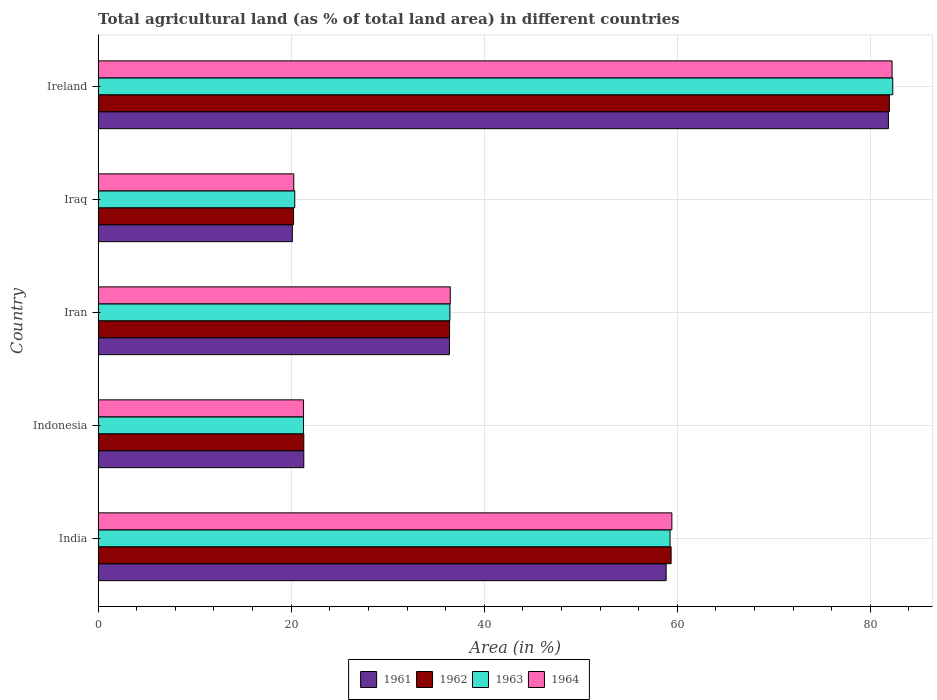Are the number of bars on each tick of the Y-axis equal?
Make the answer very short. Yes. What is the label of the 5th group of bars from the top?
Your answer should be compact. India. What is the percentage of agricultural land in 1963 in Indonesia?
Your answer should be compact. 21.28. Across all countries, what is the maximum percentage of agricultural land in 1962?
Ensure brevity in your answer.  81.97. Across all countries, what is the minimum percentage of agricultural land in 1964?
Offer a very short reply. 20.27. In which country was the percentage of agricultural land in 1964 maximum?
Give a very brief answer. Ireland. In which country was the percentage of agricultural land in 1962 minimum?
Your answer should be compact. Iraq. What is the total percentage of agricultural land in 1964 in the graph?
Provide a short and direct response. 219.71. What is the difference between the percentage of agricultural land in 1963 in Indonesia and that in Iraq?
Your response must be concise. 0.91. What is the difference between the percentage of agricultural land in 1962 in India and the percentage of agricultural land in 1961 in Iran?
Keep it short and to the point. 22.96. What is the average percentage of agricultural land in 1963 per country?
Offer a terse response. 43.93. What is the difference between the percentage of agricultural land in 1961 and percentage of agricultural land in 1964 in India?
Provide a short and direct response. -0.59. In how many countries, is the percentage of agricultural land in 1961 greater than 28 %?
Provide a short and direct response. 3. What is the ratio of the percentage of agricultural land in 1961 in Indonesia to that in Ireland?
Your answer should be compact. 0.26. Is the percentage of agricultural land in 1961 in India less than that in Iran?
Your answer should be compact. No. What is the difference between the highest and the second highest percentage of agricultural land in 1961?
Offer a terse response. 23.03. What is the difference between the highest and the lowest percentage of agricultural land in 1964?
Offer a very short reply. 61.98. Is the sum of the percentage of agricultural land in 1963 in Indonesia and Ireland greater than the maximum percentage of agricultural land in 1962 across all countries?
Ensure brevity in your answer.  Yes. What does the 4th bar from the top in Indonesia represents?
Provide a succinct answer. 1961. How many bars are there?
Your response must be concise. 20. Are all the bars in the graph horizontal?
Offer a very short reply. Yes. How many countries are there in the graph?
Your answer should be very brief. 5. What is the difference between two consecutive major ticks on the X-axis?
Provide a succinct answer. 20. Does the graph contain any zero values?
Your answer should be compact. No. How are the legend labels stacked?
Give a very brief answer. Horizontal. What is the title of the graph?
Offer a terse response. Total agricultural land (as % of total land area) in different countries. What is the label or title of the X-axis?
Make the answer very short. Area (in %). What is the Area (in %) of 1961 in India?
Provide a succinct answer. 58.84. What is the Area (in %) of 1962 in India?
Your answer should be very brief. 59.36. What is the Area (in %) in 1963 in India?
Your answer should be very brief. 59.25. What is the Area (in %) in 1964 in India?
Keep it short and to the point. 59.44. What is the Area (in %) of 1961 in Indonesia?
Make the answer very short. 21.31. What is the Area (in %) in 1962 in Indonesia?
Keep it short and to the point. 21.31. What is the Area (in %) in 1963 in Indonesia?
Your answer should be very brief. 21.28. What is the Area (in %) of 1964 in Indonesia?
Offer a terse response. 21.28. What is the Area (in %) in 1961 in Iran?
Make the answer very short. 36.39. What is the Area (in %) of 1962 in Iran?
Your answer should be very brief. 36.41. What is the Area (in %) of 1963 in Iran?
Your response must be concise. 36.44. What is the Area (in %) in 1964 in Iran?
Your answer should be compact. 36.48. What is the Area (in %) in 1961 in Iraq?
Your answer should be compact. 20.12. What is the Area (in %) in 1962 in Iraq?
Provide a succinct answer. 20.25. What is the Area (in %) in 1963 in Iraq?
Offer a very short reply. 20.37. What is the Area (in %) in 1964 in Iraq?
Offer a terse response. 20.27. What is the Area (in %) of 1961 in Ireland?
Keep it short and to the point. 81.87. What is the Area (in %) in 1962 in Ireland?
Make the answer very short. 81.97. What is the Area (in %) of 1963 in Ireland?
Your answer should be very brief. 82.32. What is the Area (in %) in 1964 in Ireland?
Ensure brevity in your answer.  82.25. Across all countries, what is the maximum Area (in %) in 1961?
Your answer should be compact. 81.87. Across all countries, what is the maximum Area (in %) of 1962?
Your answer should be very brief. 81.97. Across all countries, what is the maximum Area (in %) in 1963?
Make the answer very short. 82.32. Across all countries, what is the maximum Area (in %) of 1964?
Offer a very short reply. 82.25. Across all countries, what is the minimum Area (in %) in 1961?
Your response must be concise. 20.12. Across all countries, what is the minimum Area (in %) in 1962?
Keep it short and to the point. 20.25. Across all countries, what is the minimum Area (in %) in 1963?
Give a very brief answer. 20.37. Across all countries, what is the minimum Area (in %) in 1964?
Your answer should be compact. 20.27. What is the total Area (in %) in 1961 in the graph?
Your answer should be very brief. 218.54. What is the total Area (in %) in 1962 in the graph?
Provide a succinct answer. 219.29. What is the total Area (in %) in 1963 in the graph?
Your response must be concise. 219.66. What is the total Area (in %) of 1964 in the graph?
Provide a succinct answer. 219.71. What is the difference between the Area (in %) in 1961 in India and that in Indonesia?
Provide a succinct answer. 37.54. What is the difference between the Area (in %) in 1962 in India and that in Indonesia?
Offer a terse response. 38.05. What is the difference between the Area (in %) in 1963 in India and that in Indonesia?
Make the answer very short. 37.97. What is the difference between the Area (in %) of 1964 in India and that in Indonesia?
Keep it short and to the point. 38.16. What is the difference between the Area (in %) of 1961 in India and that in Iran?
Give a very brief answer. 22.45. What is the difference between the Area (in %) in 1962 in India and that in Iran?
Offer a terse response. 22.95. What is the difference between the Area (in %) in 1963 in India and that in Iran?
Give a very brief answer. 22.8. What is the difference between the Area (in %) in 1964 in India and that in Iran?
Your answer should be compact. 22.95. What is the difference between the Area (in %) in 1961 in India and that in Iraq?
Your response must be concise. 38.72. What is the difference between the Area (in %) in 1962 in India and that in Iraq?
Make the answer very short. 39.11. What is the difference between the Area (in %) of 1963 in India and that in Iraq?
Keep it short and to the point. 38.88. What is the difference between the Area (in %) of 1964 in India and that in Iraq?
Provide a succinct answer. 39.17. What is the difference between the Area (in %) of 1961 in India and that in Ireland?
Ensure brevity in your answer.  -23.03. What is the difference between the Area (in %) of 1962 in India and that in Ireland?
Provide a succinct answer. -22.61. What is the difference between the Area (in %) of 1963 in India and that in Ireland?
Your answer should be very brief. -23.07. What is the difference between the Area (in %) of 1964 in India and that in Ireland?
Keep it short and to the point. -22.81. What is the difference between the Area (in %) in 1961 in Indonesia and that in Iran?
Ensure brevity in your answer.  -15.09. What is the difference between the Area (in %) of 1962 in Indonesia and that in Iran?
Keep it short and to the point. -15.1. What is the difference between the Area (in %) in 1963 in Indonesia and that in Iran?
Offer a terse response. -15.16. What is the difference between the Area (in %) in 1964 in Indonesia and that in Iran?
Your answer should be very brief. -15.2. What is the difference between the Area (in %) of 1961 in Indonesia and that in Iraq?
Ensure brevity in your answer.  1.19. What is the difference between the Area (in %) of 1962 in Indonesia and that in Iraq?
Offer a very short reply. 1.06. What is the difference between the Area (in %) of 1963 in Indonesia and that in Iraq?
Your answer should be very brief. 0.91. What is the difference between the Area (in %) in 1964 in Indonesia and that in Iraq?
Make the answer very short. 1.01. What is the difference between the Area (in %) in 1961 in Indonesia and that in Ireland?
Your response must be concise. -60.56. What is the difference between the Area (in %) in 1962 in Indonesia and that in Ireland?
Provide a short and direct response. -60.66. What is the difference between the Area (in %) in 1963 in Indonesia and that in Ireland?
Give a very brief answer. -61.04. What is the difference between the Area (in %) in 1964 in Indonesia and that in Ireland?
Give a very brief answer. -60.97. What is the difference between the Area (in %) in 1961 in Iran and that in Iraq?
Ensure brevity in your answer.  16.27. What is the difference between the Area (in %) of 1962 in Iran and that in Iraq?
Your answer should be compact. 16.16. What is the difference between the Area (in %) in 1963 in Iran and that in Iraq?
Offer a very short reply. 16.07. What is the difference between the Area (in %) in 1964 in Iran and that in Iraq?
Your response must be concise. 16.21. What is the difference between the Area (in %) in 1961 in Iran and that in Ireland?
Keep it short and to the point. -45.47. What is the difference between the Area (in %) in 1962 in Iran and that in Ireland?
Ensure brevity in your answer.  -45.56. What is the difference between the Area (in %) of 1963 in Iran and that in Ireland?
Provide a succinct answer. -45.88. What is the difference between the Area (in %) in 1964 in Iran and that in Ireland?
Keep it short and to the point. -45.77. What is the difference between the Area (in %) in 1961 in Iraq and that in Ireland?
Provide a succinct answer. -61.75. What is the difference between the Area (in %) in 1962 in Iraq and that in Ireland?
Give a very brief answer. -61.73. What is the difference between the Area (in %) of 1963 in Iraq and that in Ireland?
Make the answer very short. -61.95. What is the difference between the Area (in %) of 1964 in Iraq and that in Ireland?
Provide a succinct answer. -61.98. What is the difference between the Area (in %) in 1961 in India and the Area (in %) in 1962 in Indonesia?
Offer a very short reply. 37.54. What is the difference between the Area (in %) in 1961 in India and the Area (in %) in 1963 in Indonesia?
Keep it short and to the point. 37.56. What is the difference between the Area (in %) of 1961 in India and the Area (in %) of 1964 in Indonesia?
Provide a short and direct response. 37.56. What is the difference between the Area (in %) in 1962 in India and the Area (in %) in 1963 in Indonesia?
Give a very brief answer. 38.08. What is the difference between the Area (in %) of 1962 in India and the Area (in %) of 1964 in Indonesia?
Ensure brevity in your answer.  38.08. What is the difference between the Area (in %) of 1963 in India and the Area (in %) of 1964 in Indonesia?
Your response must be concise. 37.97. What is the difference between the Area (in %) in 1961 in India and the Area (in %) in 1962 in Iran?
Offer a very short reply. 22.44. What is the difference between the Area (in %) of 1961 in India and the Area (in %) of 1963 in Iran?
Provide a succinct answer. 22.4. What is the difference between the Area (in %) in 1961 in India and the Area (in %) in 1964 in Iran?
Provide a short and direct response. 22.36. What is the difference between the Area (in %) of 1962 in India and the Area (in %) of 1963 in Iran?
Offer a very short reply. 22.91. What is the difference between the Area (in %) of 1962 in India and the Area (in %) of 1964 in Iran?
Offer a very short reply. 22.88. What is the difference between the Area (in %) in 1963 in India and the Area (in %) in 1964 in Iran?
Offer a very short reply. 22.77. What is the difference between the Area (in %) of 1961 in India and the Area (in %) of 1962 in Iraq?
Keep it short and to the point. 38.6. What is the difference between the Area (in %) in 1961 in India and the Area (in %) in 1963 in Iraq?
Offer a terse response. 38.47. What is the difference between the Area (in %) of 1961 in India and the Area (in %) of 1964 in Iraq?
Provide a succinct answer. 38.57. What is the difference between the Area (in %) of 1962 in India and the Area (in %) of 1963 in Iraq?
Give a very brief answer. 38.99. What is the difference between the Area (in %) of 1962 in India and the Area (in %) of 1964 in Iraq?
Make the answer very short. 39.09. What is the difference between the Area (in %) in 1963 in India and the Area (in %) in 1964 in Iraq?
Offer a terse response. 38.98. What is the difference between the Area (in %) of 1961 in India and the Area (in %) of 1962 in Ireland?
Give a very brief answer. -23.13. What is the difference between the Area (in %) of 1961 in India and the Area (in %) of 1963 in Ireland?
Provide a succinct answer. -23.48. What is the difference between the Area (in %) in 1961 in India and the Area (in %) in 1964 in Ireland?
Keep it short and to the point. -23.4. What is the difference between the Area (in %) of 1962 in India and the Area (in %) of 1963 in Ireland?
Your answer should be very brief. -22.96. What is the difference between the Area (in %) of 1962 in India and the Area (in %) of 1964 in Ireland?
Your response must be concise. -22.89. What is the difference between the Area (in %) in 1963 in India and the Area (in %) in 1964 in Ireland?
Make the answer very short. -23. What is the difference between the Area (in %) in 1961 in Indonesia and the Area (in %) in 1962 in Iran?
Give a very brief answer. -15.1. What is the difference between the Area (in %) of 1961 in Indonesia and the Area (in %) of 1963 in Iran?
Provide a short and direct response. -15.14. What is the difference between the Area (in %) of 1961 in Indonesia and the Area (in %) of 1964 in Iran?
Keep it short and to the point. -15.17. What is the difference between the Area (in %) of 1962 in Indonesia and the Area (in %) of 1963 in Iran?
Give a very brief answer. -15.14. What is the difference between the Area (in %) of 1962 in Indonesia and the Area (in %) of 1964 in Iran?
Make the answer very short. -15.17. What is the difference between the Area (in %) in 1963 in Indonesia and the Area (in %) in 1964 in Iran?
Give a very brief answer. -15.2. What is the difference between the Area (in %) of 1961 in Indonesia and the Area (in %) of 1962 in Iraq?
Your response must be concise. 1.06. What is the difference between the Area (in %) in 1961 in Indonesia and the Area (in %) in 1963 in Iraq?
Keep it short and to the point. 0.94. What is the difference between the Area (in %) in 1961 in Indonesia and the Area (in %) in 1964 in Iraq?
Ensure brevity in your answer.  1.04. What is the difference between the Area (in %) of 1962 in Indonesia and the Area (in %) of 1963 in Iraq?
Offer a very short reply. 0.94. What is the difference between the Area (in %) in 1962 in Indonesia and the Area (in %) in 1964 in Iraq?
Offer a very short reply. 1.04. What is the difference between the Area (in %) of 1961 in Indonesia and the Area (in %) of 1962 in Ireland?
Offer a terse response. -60.66. What is the difference between the Area (in %) in 1961 in Indonesia and the Area (in %) in 1963 in Ireland?
Provide a succinct answer. -61.01. What is the difference between the Area (in %) in 1961 in Indonesia and the Area (in %) in 1964 in Ireland?
Make the answer very short. -60.94. What is the difference between the Area (in %) in 1962 in Indonesia and the Area (in %) in 1963 in Ireland?
Keep it short and to the point. -61.01. What is the difference between the Area (in %) in 1962 in Indonesia and the Area (in %) in 1964 in Ireland?
Keep it short and to the point. -60.94. What is the difference between the Area (in %) in 1963 in Indonesia and the Area (in %) in 1964 in Ireland?
Offer a terse response. -60.97. What is the difference between the Area (in %) of 1961 in Iran and the Area (in %) of 1962 in Iraq?
Ensure brevity in your answer.  16.15. What is the difference between the Area (in %) in 1961 in Iran and the Area (in %) in 1963 in Iraq?
Make the answer very short. 16.02. What is the difference between the Area (in %) in 1961 in Iran and the Area (in %) in 1964 in Iraq?
Your answer should be very brief. 16.13. What is the difference between the Area (in %) of 1962 in Iran and the Area (in %) of 1963 in Iraq?
Make the answer very short. 16.03. What is the difference between the Area (in %) of 1962 in Iran and the Area (in %) of 1964 in Iraq?
Your answer should be very brief. 16.14. What is the difference between the Area (in %) in 1963 in Iran and the Area (in %) in 1964 in Iraq?
Your answer should be compact. 16.17. What is the difference between the Area (in %) of 1961 in Iran and the Area (in %) of 1962 in Ireland?
Provide a short and direct response. -45.58. What is the difference between the Area (in %) of 1961 in Iran and the Area (in %) of 1963 in Ireland?
Offer a very short reply. -45.92. What is the difference between the Area (in %) of 1961 in Iran and the Area (in %) of 1964 in Ireland?
Keep it short and to the point. -45.85. What is the difference between the Area (in %) of 1962 in Iran and the Area (in %) of 1963 in Ireland?
Your answer should be compact. -45.91. What is the difference between the Area (in %) in 1962 in Iran and the Area (in %) in 1964 in Ireland?
Give a very brief answer. -45.84. What is the difference between the Area (in %) in 1963 in Iran and the Area (in %) in 1964 in Ireland?
Offer a very short reply. -45.8. What is the difference between the Area (in %) in 1961 in Iraq and the Area (in %) in 1962 in Ireland?
Give a very brief answer. -61.85. What is the difference between the Area (in %) in 1961 in Iraq and the Area (in %) in 1963 in Ireland?
Your answer should be very brief. -62.2. What is the difference between the Area (in %) of 1961 in Iraq and the Area (in %) of 1964 in Ireland?
Provide a succinct answer. -62.13. What is the difference between the Area (in %) of 1962 in Iraq and the Area (in %) of 1963 in Ireland?
Ensure brevity in your answer.  -62.07. What is the difference between the Area (in %) in 1962 in Iraq and the Area (in %) in 1964 in Ireland?
Give a very brief answer. -62. What is the difference between the Area (in %) of 1963 in Iraq and the Area (in %) of 1964 in Ireland?
Your answer should be very brief. -61.88. What is the average Area (in %) in 1961 per country?
Your answer should be compact. 43.71. What is the average Area (in %) in 1962 per country?
Offer a very short reply. 43.86. What is the average Area (in %) of 1963 per country?
Your answer should be very brief. 43.93. What is the average Area (in %) in 1964 per country?
Ensure brevity in your answer.  43.94. What is the difference between the Area (in %) in 1961 and Area (in %) in 1962 in India?
Give a very brief answer. -0.51. What is the difference between the Area (in %) of 1961 and Area (in %) of 1963 in India?
Make the answer very short. -0.4. What is the difference between the Area (in %) of 1961 and Area (in %) of 1964 in India?
Make the answer very short. -0.59. What is the difference between the Area (in %) of 1962 and Area (in %) of 1963 in India?
Give a very brief answer. 0.11. What is the difference between the Area (in %) in 1962 and Area (in %) in 1964 in India?
Make the answer very short. -0.08. What is the difference between the Area (in %) in 1963 and Area (in %) in 1964 in India?
Make the answer very short. -0.19. What is the difference between the Area (in %) in 1961 and Area (in %) in 1963 in Indonesia?
Offer a terse response. 0.03. What is the difference between the Area (in %) in 1961 and Area (in %) in 1964 in Indonesia?
Give a very brief answer. 0.03. What is the difference between the Area (in %) of 1962 and Area (in %) of 1963 in Indonesia?
Provide a succinct answer. 0.03. What is the difference between the Area (in %) in 1962 and Area (in %) in 1964 in Indonesia?
Provide a succinct answer. 0.03. What is the difference between the Area (in %) of 1963 and Area (in %) of 1964 in Indonesia?
Provide a succinct answer. 0. What is the difference between the Area (in %) in 1961 and Area (in %) in 1962 in Iran?
Your answer should be compact. -0.01. What is the difference between the Area (in %) in 1961 and Area (in %) in 1963 in Iran?
Offer a terse response. -0.05. What is the difference between the Area (in %) in 1961 and Area (in %) in 1964 in Iran?
Provide a short and direct response. -0.09. What is the difference between the Area (in %) in 1962 and Area (in %) in 1963 in Iran?
Offer a terse response. -0.04. What is the difference between the Area (in %) of 1962 and Area (in %) of 1964 in Iran?
Offer a terse response. -0.07. What is the difference between the Area (in %) in 1963 and Area (in %) in 1964 in Iran?
Offer a terse response. -0.04. What is the difference between the Area (in %) of 1961 and Area (in %) of 1962 in Iraq?
Make the answer very short. -0.13. What is the difference between the Area (in %) in 1961 and Area (in %) in 1963 in Iraq?
Provide a succinct answer. -0.25. What is the difference between the Area (in %) in 1961 and Area (in %) in 1964 in Iraq?
Ensure brevity in your answer.  -0.15. What is the difference between the Area (in %) of 1962 and Area (in %) of 1963 in Iraq?
Offer a terse response. -0.13. What is the difference between the Area (in %) in 1962 and Area (in %) in 1964 in Iraq?
Your response must be concise. -0.02. What is the difference between the Area (in %) in 1963 and Area (in %) in 1964 in Iraq?
Ensure brevity in your answer.  0.1. What is the difference between the Area (in %) of 1961 and Area (in %) of 1962 in Ireland?
Your response must be concise. -0.1. What is the difference between the Area (in %) of 1961 and Area (in %) of 1963 in Ireland?
Your response must be concise. -0.45. What is the difference between the Area (in %) of 1961 and Area (in %) of 1964 in Ireland?
Offer a terse response. -0.38. What is the difference between the Area (in %) of 1962 and Area (in %) of 1963 in Ireland?
Offer a very short reply. -0.35. What is the difference between the Area (in %) of 1962 and Area (in %) of 1964 in Ireland?
Offer a terse response. -0.28. What is the difference between the Area (in %) in 1963 and Area (in %) in 1964 in Ireland?
Provide a short and direct response. 0.07. What is the ratio of the Area (in %) in 1961 in India to that in Indonesia?
Give a very brief answer. 2.76. What is the ratio of the Area (in %) of 1962 in India to that in Indonesia?
Provide a succinct answer. 2.79. What is the ratio of the Area (in %) in 1963 in India to that in Indonesia?
Provide a short and direct response. 2.78. What is the ratio of the Area (in %) of 1964 in India to that in Indonesia?
Ensure brevity in your answer.  2.79. What is the ratio of the Area (in %) in 1961 in India to that in Iran?
Ensure brevity in your answer.  1.62. What is the ratio of the Area (in %) in 1962 in India to that in Iran?
Ensure brevity in your answer.  1.63. What is the ratio of the Area (in %) of 1963 in India to that in Iran?
Provide a succinct answer. 1.63. What is the ratio of the Area (in %) of 1964 in India to that in Iran?
Your response must be concise. 1.63. What is the ratio of the Area (in %) of 1961 in India to that in Iraq?
Your answer should be very brief. 2.92. What is the ratio of the Area (in %) of 1962 in India to that in Iraq?
Offer a terse response. 2.93. What is the ratio of the Area (in %) of 1963 in India to that in Iraq?
Ensure brevity in your answer.  2.91. What is the ratio of the Area (in %) of 1964 in India to that in Iraq?
Your response must be concise. 2.93. What is the ratio of the Area (in %) of 1961 in India to that in Ireland?
Your response must be concise. 0.72. What is the ratio of the Area (in %) in 1962 in India to that in Ireland?
Ensure brevity in your answer.  0.72. What is the ratio of the Area (in %) in 1963 in India to that in Ireland?
Give a very brief answer. 0.72. What is the ratio of the Area (in %) in 1964 in India to that in Ireland?
Provide a succinct answer. 0.72. What is the ratio of the Area (in %) of 1961 in Indonesia to that in Iran?
Your response must be concise. 0.59. What is the ratio of the Area (in %) of 1962 in Indonesia to that in Iran?
Ensure brevity in your answer.  0.59. What is the ratio of the Area (in %) in 1963 in Indonesia to that in Iran?
Give a very brief answer. 0.58. What is the ratio of the Area (in %) of 1964 in Indonesia to that in Iran?
Ensure brevity in your answer.  0.58. What is the ratio of the Area (in %) in 1961 in Indonesia to that in Iraq?
Your response must be concise. 1.06. What is the ratio of the Area (in %) in 1962 in Indonesia to that in Iraq?
Your response must be concise. 1.05. What is the ratio of the Area (in %) in 1963 in Indonesia to that in Iraq?
Provide a short and direct response. 1.04. What is the ratio of the Area (in %) in 1964 in Indonesia to that in Iraq?
Ensure brevity in your answer.  1.05. What is the ratio of the Area (in %) in 1961 in Indonesia to that in Ireland?
Make the answer very short. 0.26. What is the ratio of the Area (in %) in 1962 in Indonesia to that in Ireland?
Your response must be concise. 0.26. What is the ratio of the Area (in %) in 1963 in Indonesia to that in Ireland?
Make the answer very short. 0.26. What is the ratio of the Area (in %) in 1964 in Indonesia to that in Ireland?
Offer a very short reply. 0.26. What is the ratio of the Area (in %) in 1961 in Iran to that in Iraq?
Offer a terse response. 1.81. What is the ratio of the Area (in %) in 1962 in Iran to that in Iraq?
Offer a very short reply. 1.8. What is the ratio of the Area (in %) in 1963 in Iran to that in Iraq?
Give a very brief answer. 1.79. What is the ratio of the Area (in %) in 1964 in Iran to that in Iraq?
Offer a very short reply. 1.8. What is the ratio of the Area (in %) of 1961 in Iran to that in Ireland?
Provide a succinct answer. 0.44. What is the ratio of the Area (in %) in 1962 in Iran to that in Ireland?
Your answer should be very brief. 0.44. What is the ratio of the Area (in %) in 1963 in Iran to that in Ireland?
Give a very brief answer. 0.44. What is the ratio of the Area (in %) in 1964 in Iran to that in Ireland?
Keep it short and to the point. 0.44. What is the ratio of the Area (in %) of 1961 in Iraq to that in Ireland?
Keep it short and to the point. 0.25. What is the ratio of the Area (in %) in 1962 in Iraq to that in Ireland?
Provide a short and direct response. 0.25. What is the ratio of the Area (in %) of 1963 in Iraq to that in Ireland?
Your response must be concise. 0.25. What is the ratio of the Area (in %) of 1964 in Iraq to that in Ireland?
Keep it short and to the point. 0.25. What is the difference between the highest and the second highest Area (in %) in 1961?
Provide a short and direct response. 23.03. What is the difference between the highest and the second highest Area (in %) in 1962?
Provide a succinct answer. 22.61. What is the difference between the highest and the second highest Area (in %) in 1963?
Provide a succinct answer. 23.07. What is the difference between the highest and the second highest Area (in %) in 1964?
Ensure brevity in your answer.  22.81. What is the difference between the highest and the lowest Area (in %) in 1961?
Your response must be concise. 61.75. What is the difference between the highest and the lowest Area (in %) of 1962?
Provide a short and direct response. 61.73. What is the difference between the highest and the lowest Area (in %) in 1963?
Ensure brevity in your answer.  61.95. What is the difference between the highest and the lowest Area (in %) of 1964?
Give a very brief answer. 61.98. 